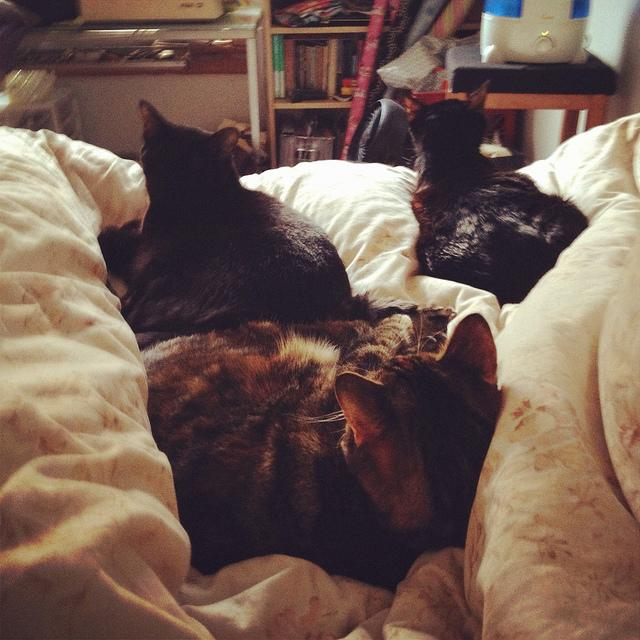What air quality problem occurs in this bedroom? Please explain your reasoning. low humidity. The problem is low humidity. 